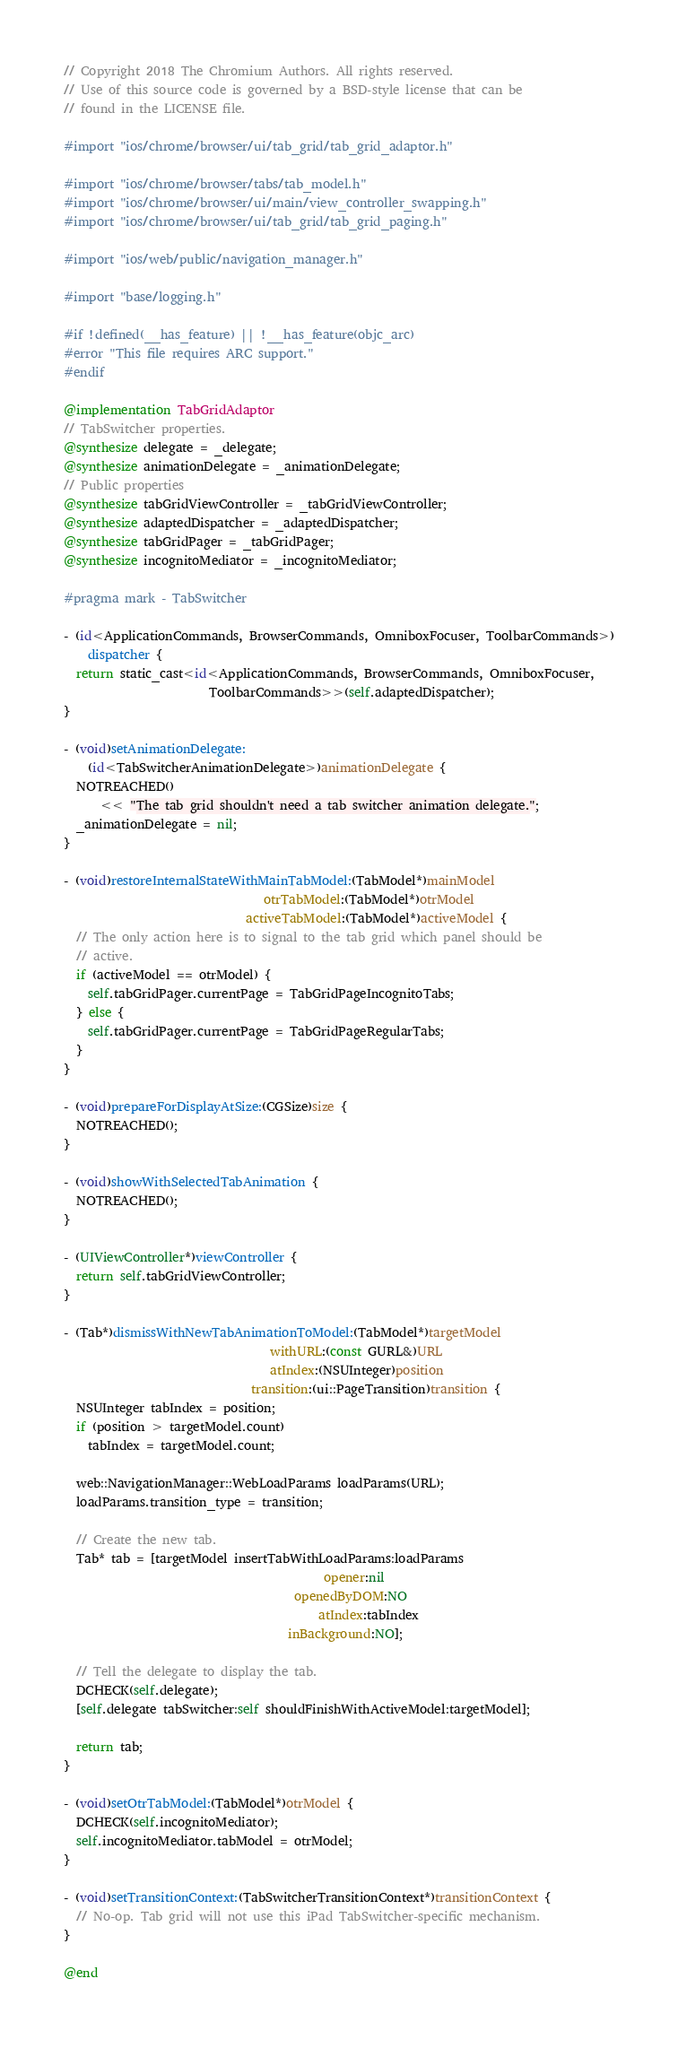Convert code to text. <code><loc_0><loc_0><loc_500><loc_500><_ObjectiveC_>// Copyright 2018 The Chromium Authors. All rights reserved.
// Use of this source code is governed by a BSD-style license that can be
// found in the LICENSE file.

#import "ios/chrome/browser/ui/tab_grid/tab_grid_adaptor.h"

#import "ios/chrome/browser/tabs/tab_model.h"
#import "ios/chrome/browser/ui/main/view_controller_swapping.h"
#import "ios/chrome/browser/ui/tab_grid/tab_grid_paging.h"

#import "ios/web/public/navigation_manager.h"

#import "base/logging.h"

#if !defined(__has_feature) || !__has_feature(objc_arc)
#error "This file requires ARC support."
#endif

@implementation TabGridAdaptor
// TabSwitcher properties.
@synthesize delegate = _delegate;
@synthesize animationDelegate = _animationDelegate;
// Public properties
@synthesize tabGridViewController = _tabGridViewController;
@synthesize adaptedDispatcher = _adaptedDispatcher;
@synthesize tabGridPager = _tabGridPager;
@synthesize incognitoMediator = _incognitoMediator;

#pragma mark - TabSwitcher

- (id<ApplicationCommands, BrowserCommands, OmniboxFocuser, ToolbarCommands>)
    dispatcher {
  return static_cast<id<ApplicationCommands, BrowserCommands, OmniboxFocuser,
                        ToolbarCommands>>(self.adaptedDispatcher);
}

- (void)setAnimationDelegate:
    (id<TabSwitcherAnimationDelegate>)animationDelegate {
  NOTREACHED()
      << "The tab grid shouldn't need a tab switcher animation delegate.";
  _animationDelegate = nil;
}

- (void)restoreInternalStateWithMainTabModel:(TabModel*)mainModel
                                 otrTabModel:(TabModel*)otrModel
                              activeTabModel:(TabModel*)activeModel {
  // The only action here is to signal to the tab grid which panel should be
  // active.
  if (activeModel == otrModel) {
    self.tabGridPager.currentPage = TabGridPageIncognitoTabs;
  } else {
    self.tabGridPager.currentPage = TabGridPageRegularTabs;
  }
}

- (void)prepareForDisplayAtSize:(CGSize)size {
  NOTREACHED();
}

- (void)showWithSelectedTabAnimation {
  NOTREACHED();
}

- (UIViewController*)viewController {
  return self.tabGridViewController;
}

- (Tab*)dismissWithNewTabAnimationToModel:(TabModel*)targetModel
                                  withURL:(const GURL&)URL
                                  atIndex:(NSUInteger)position
                               transition:(ui::PageTransition)transition {
  NSUInteger tabIndex = position;
  if (position > targetModel.count)
    tabIndex = targetModel.count;

  web::NavigationManager::WebLoadParams loadParams(URL);
  loadParams.transition_type = transition;

  // Create the new tab.
  Tab* tab = [targetModel insertTabWithLoadParams:loadParams
                                           opener:nil
                                      openedByDOM:NO
                                          atIndex:tabIndex
                                     inBackground:NO];

  // Tell the delegate to display the tab.
  DCHECK(self.delegate);
  [self.delegate tabSwitcher:self shouldFinishWithActiveModel:targetModel];

  return tab;
}

- (void)setOtrTabModel:(TabModel*)otrModel {
  DCHECK(self.incognitoMediator);
  self.incognitoMediator.tabModel = otrModel;
}

- (void)setTransitionContext:(TabSwitcherTransitionContext*)transitionContext {
  // No-op. Tab grid will not use this iPad TabSwitcher-specific mechanism.
}

@end
</code> 